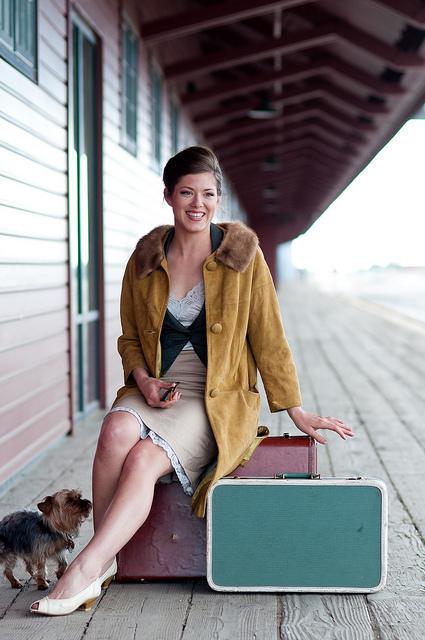What is the girl holding?
Quick response, please. Phone. Is the woman wearing a dress?
Answer briefly. Yes. What kind of dog is this?
Short answer required. Yorkie. What color luggage is the woman sitting on?
Give a very brief answer. Red. Where is she sitting?
Quick response, please. On suitcase. 